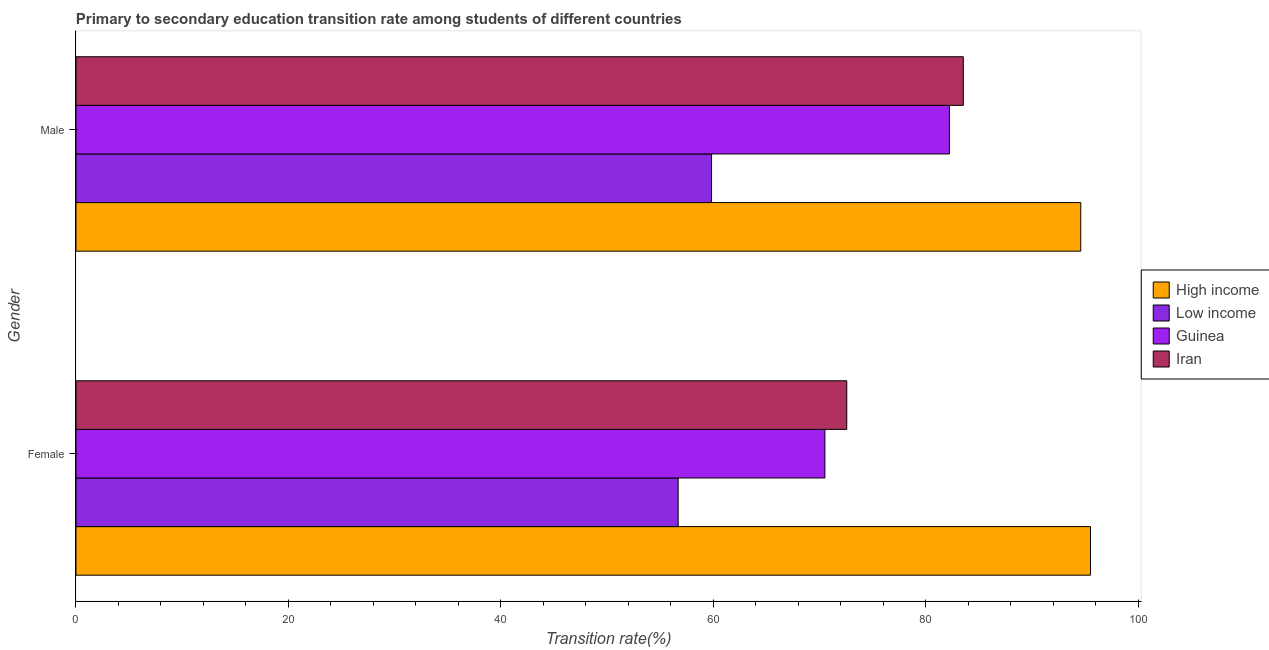How many groups of bars are there?
Your response must be concise. 2. Are the number of bars on each tick of the Y-axis equal?
Keep it short and to the point. Yes. What is the label of the 2nd group of bars from the top?
Offer a terse response. Female. What is the transition rate among female students in High income?
Keep it short and to the point. 95.49. Across all countries, what is the maximum transition rate among female students?
Your response must be concise. 95.49. Across all countries, what is the minimum transition rate among female students?
Make the answer very short. 56.68. In which country was the transition rate among male students maximum?
Offer a terse response. High income. What is the total transition rate among female students in the graph?
Your answer should be very brief. 295.21. What is the difference between the transition rate among female students in Guinea and that in High income?
Give a very brief answer. -25. What is the difference between the transition rate among male students in Low income and the transition rate among female students in Iran?
Your response must be concise. -12.73. What is the average transition rate among female students per country?
Give a very brief answer. 73.8. What is the difference between the transition rate among female students and transition rate among male students in Low income?
Make the answer very short. -3.14. What is the ratio of the transition rate among female students in Iran to that in High income?
Ensure brevity in your answer.  0.76. Are all the bars in the graph horizontal?
Give a very brief answer. Yes. What is the difference between two consecutive major ticks on the X-axis?
Your answer should be very brief. 20. Does the graph contain any zero values?
Give a very brief answer. No. Where does the legend appear in the graph?
Give a very brief answer. Center right. How many legend labels are there?
Offer a terse response. 4. How are the legend labels stacked?
Keep it short and to the point. Vertical. What is the title of the graph?
Keep it short and to the point. Primary to secondary education transition rate among students of different countries. What is the label or title of the X-axis?
Provide a succinct answer. Transition rate(%). What is the Transition rate(%) in High income in Female?
Ensure brevity in your answer.  95.49. What is the Transition rate(%) of Low income in Female?
Offer a terse response. 56.68. What is the Transition rate(%) of Guinea in Female?
Your response must be concise. 70.49. What is the Transition rate(%) of Iran in Female?
Provide a short and direct response. 72.55. What is the Transition rate(%) in High income in Male?
Ensure brevity in your answer.  94.57. What is the Transition rate(%) of Low income in Male?
Offer a very short reply. 59.82. What is the Transition rate(%) of Guinea in Male?
Keep it short and to the point. 82.21. What is the Transition rate(%) in Iran in Male?
Your answer should be very brief. 83.52. Across all Gender, what is the maximum Transition rate(%) of High income?
Offer a terse response. 95.49. Across all Gender, what is the maximum Transition rate(%) of Low income?
Ensure brevity in your answer.  59.82. Across all Gender, what is the maximum Transition rate(%) in Guinea?
Keep it short and to the point. 82.21. Across all Gender, what is the maximum Transition rate(%) in Iran?
Offer a terse response. 83.52. Across all Gender, what is the minimum Transition rate(%) of High income?
Provide a succinct answer. 94.57. Across all Gender, what is the minimum Transition rate(%) in Low income?
Make the answer very short. 56.68. Across all Gender, what is the minimum Transition rate(%) of Guinea?
Provide a succinct answer. 70.49. Across all Gender, what is the minimum Transition rate(%) of Iran?
Offer a terse response. 72.55. What is the total Transition rate(%) in High income in the graph?
Provide a succinct answer. 190.06. What is the total Transition rate(%) in Low income in the graph?
Provide a succinct answer. 116.5. What is the total Transition rate(%) of Guinea in the graph?
Your response must be concise. 152.7. What is the total Transition rate(%) of Iran in the graph?
Make the answer very short. 156.06. What is the difference between the Transition rate(%) in High income in Female and that in Male?
Offer a very short reply. 0.92. What is the difference between the Transition rate(%) in Low income in Female and that in Male?
Provide a short and direct response. -3.14. What is the difference between the Transition rate(%) in Guinea in Female and that in Male?
Your response must be concise. -11.72. What is the difference between the Transition rate(%) in Iran in Female and that in Male?
Your response must be concise. -10.97. What is the difference between the Transition rate(%) of High income in Female and the Transition rate(%) of Low income in Male?
Your response must be concise. 35.67. What is the difference between the Transition rate(%) in High income in Female and the Transition rate(%) in Guinea in Male?
Your answer should be very brief. 13.28. What is the difference between the Transition rate(%) in High income in Female and the Transition rate(%) in Iran in Male?
Give a very brief answer. 11.97. What is the difference between the Transition rate(%) of Low income in Female and the Transition rate(%) of Guinea in Male?
Offer a very short reply. -25.53. What is the difference between the Transition rate(%) in Low income in Female and the Transition rate(%) in Iran in Male?
Provide a short and direct response. -26.84. What is the difference between the Transition rate(%) of Guinea in Female and the Transition rate(%) of Iran in Male?
Keep it short and to the point. -13.03. What is the average Transition rate(%) in High income per Gender?
Your response must be concise. 95.03. What is the average Transition rate(%) of Low income per Gender?
Ensure brevity in your answer.  58.25. What is the average Transition rate(%) in Guinea per Gender?
Give a very brief answer. 76.35. What is the average Transition rate(%) of Iran per Gender?
Keep it short and to the point. 78.03. What is the difference between the Transition rate(%) of High income and Transition rate(%) of Low income in Female?
Provide a short and direct response. 38.81. What is the difference between the Transition rate(%) of High income and Transition rate(%) of Guinea in Female?
Keep it short and to the point. 25. What is the difference between the Transition rate(%) of High income and Transition rate(%) of Iran in Female?
Your response must be concise. 22.94. What is the difference between the Transition rate(%) of Low income and Transition rate(%) of Guinea in Female?
Provide a short and direct response. -13.81. What is the difference between the Transition rate(%) of Low income and Transition rate(%) of Iran in Female?
Make the answer very short. -15.87. What is the difference between the Transition rate(%) of Guinea and Transition rate(%) of Iran in Female?
Ensure brevity in your answer.  -2.06. What is the difference between the Transition rate(%) of High income and Transition rate(%) of Low income in Male?
Your answer should be compact. 34.75. What is the difference between the Transition rate(%) of High income and Transition rate(%) of Guinea in Male?
Provide a short and direct response. 12.36. What is the difference between the Transition rate(%) of High income and Transition rate(%) of Iran in Male?
Give a very brief answer. 11.05. What is the difference between the Transition rate(%) in Low income and Transition rate(%) in Guinea in Male?
Provide a short and direct response. -22.39. What is the difference between the Transition rate(%) in Low income and Transition rate(%) in Iran in Male?
Make the answer very short. -23.7. What is the difference between the Transition rate(%) of Guinea and Transition rate(%) of Iran in Male?
Offer a very short reply. -1.31. What is the ratio of the Transition rate(%) of High income in Female to that in Male?
Your answer should be compact. 1.01. What is the ratio of the Transition rate(%) in Low income in Female to that in Male?
Provide a short and direct response. 0.95. What is the ratio of the Transition rate(%) of Guinea in Female to that in Male?
Offer a very short reply. 0.86. What is the ratio of the Transition rate(%) in Iran in Female to that in Male?
Your response must be concise. 0.87. What is the difference between the highest and the second highest Transition rate(%) in High income?
Make the answer very short. 0.92. What is the difference between the highest and the second highest Transition rate(%) in Low income?
Your response must be concise. 3.14. What is the difference between the highest and the second highest Transition rate(%) of Guinea?
Give a very brief answer. 11.72. What is the difference between the highest and the second highest Transition rate(%) in Iran?
Keep it short and to the point. 10.97. What is the difference between the highest and the lowest Transition rate(%) in High income?
Offer a terse response. 0.92. What is the difference between the highest and the lowest Transition rate(%) of Low income?
Offer a terse response. 3.14. What is the difference between the highest and the lowest Transition rate(%) in Guinea?
Your answer should be very brief. 11.72. What is the difference between the highest and the lowest Transition rate(%) in Iran?
Offer a terse response. 10.97. 